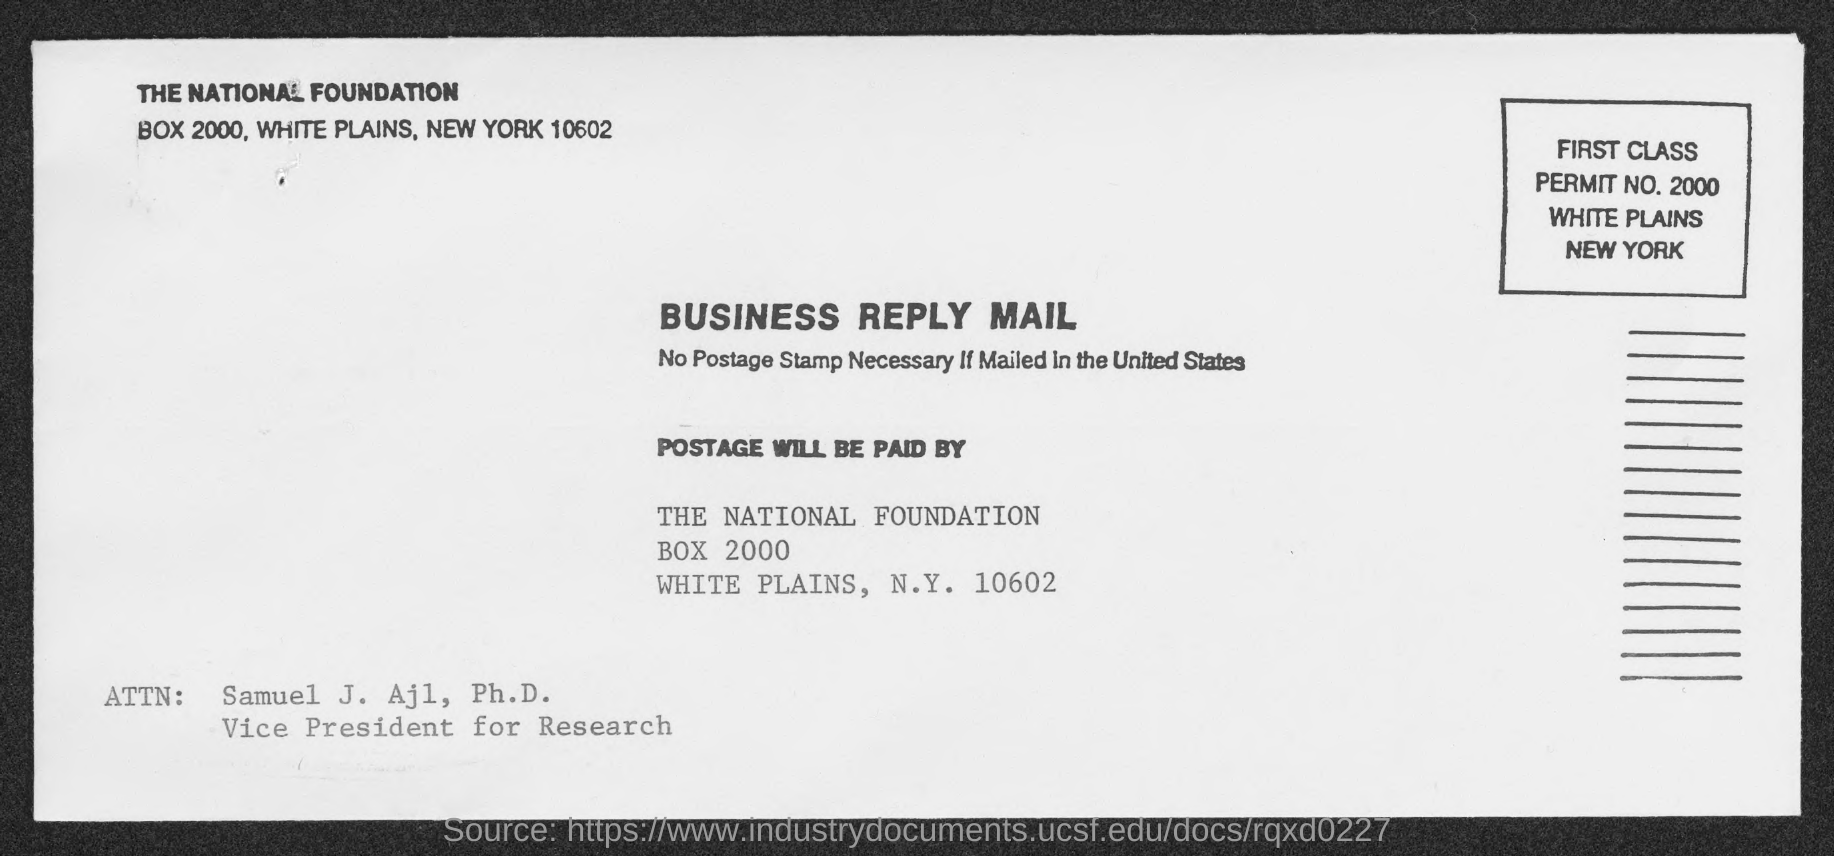Who is the vice president for research ?
Your answer should be compact. Samuel J. Ajl, Ph.D. 